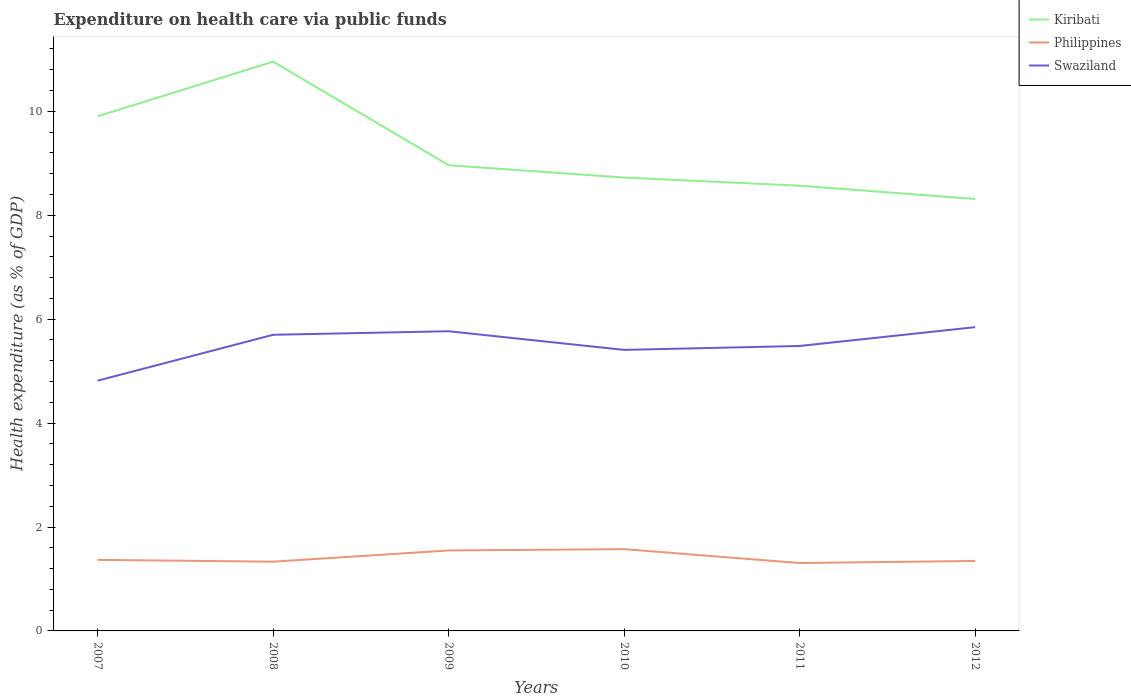How many different coloured lines are there?
Keep it short and to the point. 3. Is the number of lines equal to the number of legend labels?
Offer a terse response. Yes. Across all years, what is the maximum expenditure made on health care in Kiribati?
Offer a very short reply. 8.31. In which year was the expenditure made on health care in Philippines maximum?
Offer a terse response. 2011. What is the total expenditure made on health care in Philippines in the graph?
Keep it short and to the point. -0.04. What is the difference between the highest and the second highest expenditure made on health care in Philippines?
Keep it short and to the point. 0.27. What is the difference between the highest and the lowest expenditure made on health care in Kiribati?
Offer a terse response. 2. What is the difference between two consecutive major ticks on the Y-axis?
Give a very brief answer. 2. Does the graph contain any zero values?
Offer a very short reply. No. Does the graph contain grids?
Ensure brevity in your answer.  No. How many legend labels are there?
Your answer should be compact. 3. How are the legend labels stacked?
Offer a very short reply. Vertical. What is the title of the graph?
Provide a succinct answer. Expenditure on health care via public funds. Does "Iceland" appear as one of the legend labels in the graph?
Ensure brevity in your answer.  No. What is the label or title of the X-axis?
Give a very brief answer. Years. What is the label or title of the Y-axis?
Provide a succinct answer. Health expenditure (as % of GDP). What is the Health expenditure (as % of GDP) of Kiribati in 2007?
Keep it short and to the point. 9.9. What is the Health expenditure (as % of GDP) in Philippines in 2007?
Make the answer very short. 1.37. What is the Health expenditure (as % of GDP) of Swaziland in 2007?
Provide a short and direct response. 4.82. What is the Health expenditure (as % of GDP) of Kiribati in 2008?
Your answer should be compact. 10.96. What is the Health expenditure (as % of GDP) in Philippines in 2008?
Your answer should be very brief. 1.33. What is the Health expenditure (as % of GDP) of Swaziland in 2008?
Your answer should be very brief. 5.7. What is the Health expenditure (as % of GDP) of Kiribati in 2009?
Offer a terse response. 8.96. What is the Health expenditure (as % of GDP) in Philippines in 2009?
Give a very brief answer. 1.55. What is the Health expenditure (as % of GDP) of Swaziland in 2009?
Ensure brevity in your answer.  5.77. What is the Health expenditure (as % of GDP) of Kiribati in 2010?
Your answer should be compact. 8.73. What is the Health expenditure (as % of GDP) in Philippines in 2010?
Ensure brevity in your answer.  1.57. What is the Health expenditure (as % of GDP) in Swaziland in 2010?
Make the answer very short. 5.41. What is the Health expenditure (as % of GDP) of Kiribati in 2011?
Ensure brevity in your answer.  8.57. What is the Health expenditure (as % of GDP) of Philippines in 2011?
Give a very brief answer. 1.31. What is the Health expenditure (as % of GDP) of Swaziland in 2011?
Your response must be concise. 5.48. What is the Health expenditure (as % of GDP) of Kiribati in 2012?
Your response must be concise. 8.31. What is the Health expenditure (as % of GDP) of Philippines in 2012?
Make the answer very short. 1.35. What is the Health expenditure (as % of GDP) in Swaziland in 2012?
Your answer should be compact. 5.85. Across all years, what is the maximum Health expenditure (as % of GDP) in Kiribati?
Ensure brevity in your answer.  10.96. Across all years, what is the maximum Health expenditure (as % of GDP) in Philippines?
Your answer should be compact. 1.57. Across all years, what is the maximum Health expenditure (as % of GDP) in Swaziland?
Offer a terse response. 5.85. Across all years, what is the minimum Health expenditure (as % of GDP) in Kiribati?
Your answer should be very brief. 8.31. Across all years, what is the minimum Health expenditure (as % of GDP) of Philippines?
Your answer should be very brief. 1.31. Across all years, what is the minimum Health expenditure (as % of GDP) in Swaziland?
Provide a short and direct response. 4.82. What is the total Health expenditure (as % of GDP) in Kiribati in the graph?
Your answer should be compact. 55.43. What is the total Health expenditure (as % of GDP) in Philippines in the graph?
Offer a very short reply. 8.48. What is the total Health expenditure (as % of GDP) in Swaziland in the graph?
Provide a succinct answer. 33.02. What is the difference between the Health expenditure (as % of GDP) of Kiribati in 2007 and that in 2008?
Offer a terse response. -1.05. What is the difference between the Health expenditure (as % of GDP) in Philippines in 2007 and that in 2008?
Your answer should be very brief. 0.04. What is the difference between the Health expenditure (as % of GDP) in Swaziland in 2007 and that in 2008?
Keep it short and to the point. -0.88. What is the difference between the Health expenditure (as % of GDP) of Kiribati in 2007 and that in 2009?
Your response must be concise. 0.94. What is the difference between the Health expenditure (as % of GDP) of Philippines in 2007 and that in 2009?
Your response must be concise. -0.18. What is the difference between the Health expenditure (as % of GDP) of Swaziland in 2007 and that in 2009?
Your answer should be compact. -0.95. What is the difference between the Health expenditure (as % of GDP) in Kiribati in 2007 and that in 2010?
Provide a short and direct response. 1.18. What is the difference between the Health expenditure (as % of GDP) of Philippines in 2007 and that in 2010?
Keep it short and to the point. -0.21. What is the difference between the Health expenditure (as % of GDP) in Swaziland in 2007 and that in 2010?
Make the answer very short. -0.59. What is the difference between the Health expenditure (as % of GDP) in Kiribati in 2007 and that in 2011?
Keep it short and to the point. 1.34. What is the difference between the Health expenditure (as % of GDP) in Philippines in 2007 and that in 2011?
Give a very brief answer. 0.06. What is the difference between the Health expenditure (as % of GDP) of Swaziland in 2007 and that in 2011?
Make the answer very short. -0.67. What is the difference between the Health expenditure (as % of GDP) in Kiribati in 2007 and that in 2012?
Your answer should be very brief. 1.59. What is the difference between the Health expenditure (as % of GDP) of Philippines in 2007 and that in 2012?
Give a very brief answer. 0.02. What is the difference between the Health expenditure (as % of GDP) of Swaziland in 2007 and that in 2012?
Your answer should be very brief. -1.03. What is the difference between the Health expenditure (as % of GDP) of Kiribati in 2008 and that in 2009?
Your answer should be very brief. 1.99. What is the difference between the Health expenditure (as % of GDP) in Philippines in 2008 and that in 2009?
Make the answer very short. -0.22. What is the difference between the Health expenditure (as % of GDP) of Swaziland in 2008 and that in 2009?
Offer a very short reply. -0.07. What is the difference between the Health expenditure (as % of GDP) of Kiribati in 2008 and that in 2010?
Make the answer very short. 2.23. What is the difference between the Health expenditure (as % of GDP) of Philippines in 2008 and that in 2010?
Your answer should be very brief. -0.24. What is the difference between the Health expenditure (as % of GDP) of Swaziland in 2008 and that in 2010?
Make the answer very short. 0.29. What is the difference between the Health expenditure (as % of GDP) in Kiribati in 2008 and that in 2011?
Offer a terse response. 2.39. What is the difference between the Health expenditure (as % of GDP) of Philippines in 2008 and that in 2011?
Your answer should be very brief. 0.03. What is the difference between the Health expenditure (as % of GDP) in Swaziland in 2008 and that in 2011?
Keep it short and to the point. 0.22. What is the difference between the Health expenditure (as % of GDP) in Kiribati in 2008 and that in 2012?
Your answer should be very brief. 2.64. What is the difference between the Health expenditure (as % of GDP) in Philippines in 2008 and that in 2012?
Offer a terse response. -0.01. What is the difference between the Health expenditure (as % of GDP) of Swaziland in 2008 and that in 2012?
Provide a succinct answer. -0.15. What is the difference between the Health expenditure (as % of GDP) in Kiribati in 2009 and that in 2010?
Your response must be concise. 0.24. What is the difference between the Health expenditure (as % of GDP) of Philippines in 2009 and that in 2010?
Provide a succinct answer. -0.03. What is the difference between the Health expenditure (as % of GDP) of Swaziland in 2009 and that in 2010?
Your response must be concise. 0.36. What is the difference between the Health expenditure (as % of GDP) of Kiribati in 2009 and that in 2011?
Offer a very short reply. 0.39. What is the difference between the Health expenditure (as % of GDP) of Philippines in 2009 and that in 2011?
Offer a very short reply. 0.24. What is the difference between the Health expenditure (as % of GDP) of Swaziland in 2009 and that in 2011?
Make the answer very short. 0.28. What is the difference between the Health expenditure (as % of GDP) of Kiribati in 2009 and that in 2012?
Provide a succinct answer. 0.65. What is the difference between the Health expenditure (as % of GDP) of Philippines in 2009 and that in 2012?
Make the answer very short. 0.2. What is the difference between the Health expenditure (as % of GDP) in Swaziland in 2009 and that in 2012?
Provide a succinct answer. -0.08. What is the difference between the Health expenditure (as % of GDP) in Kiribati in 2010 and that in 2011?
Offer a very short reply. 0.16. What is the difference between the Health expenditure (as % of GDP) in Philippines in 2010 and that in 2011?
Ensure brevity in your answer.  0.27. What is the difference between the Health expenditure (as % of GDP) in Swaziland in 2010 and that in 2011?
Offer a terse response. -0.08. What is the difference between the Health expenditure (as % of GDP) in Kiribati in 2010 and that in 2012?
Give a very brief answer. 0.41. What is the difference between the Health expenditure (as % of GDP) of Philippines in 2010 and that in 2012?
Ensure brevity in your answer.  0.23. What is the difference between the Health expenditure (as % of GDP) of Swaziland in 2010 and that in 2012?
Offer a very short reply. -0.44. What is the difference between the Health expenditure (as % of GDP) in Kiribati in 2011 and that in 2012?
Offer a terse response. 0.26. What is the difference between the Health expenditure (as % of GDP) of Philippines in 2011 and that in 2012?
Provide a short and direct response. -0.04. What is the difference between the Health expenditure (as % of GDP) of Swaziland in 2011 and that in 2012?
Offer a very short reply. -0.36. What is the difference between the Health expenditure (as % of GDP) of Kiribati in 2007 and the Health expenditure (as % of GDP) of Philippines in 2008?
Offer a terse response. 8.57. What is the difference between the Health expenditure (as % of GDP) in Kiribati in 2007 and the Health expenditure (as % of GDP) in Swaziland in 2008?
Give a very brief answer. 4.21. What is the difference between the Health expenditure (as % of GDP) in Philippines in 2007 and the Health expenditure (as % of GDP) in Swaziland in 2008?
Your answer should be very brief. -4.33. What is the difference between the Health expenditure (as % of GDP) in Kiribati in 2007 and the Health expenditure (as % of GDP) in Philippines in 2009?
Give a very brief answer. 8.36. What is the difference between the Health expenditure (as % of GDP) in Kiribati in 2007 and the Health expenditure (as % of GDP) in Swaziland in 2009?
Offer a very short reply. 4.14. What is the difference between the Health expenditure (as % of GDP) of Philippines in 2007 and the Health expenditure (as % of GDP) of Swaziland in 2009?
Provide a succinct answer. -4.4. What is the difference between the Health expenditure (as % of GDP) in Kiribati in 2007 and the Health expenditure (as % of GDP) in Philippines in 2010?
Provide a succinct answer. 8.33. What is the difference between the Health expenditure (as % of GDP) in Kiribati in 2007 and the Health expenditure (as % of GDP) in Swaziland in 2010?
Provide a succinct answer. 4.5. What is the difference between the Health expenditure (as % of GDP) in Philippines in 2007 and the Health expenditure (as % of GDP) in Swaziland in 2010?
Keep it short and to the point. -4.04. What is the difference between the Health expenditure (as % of GDP) in Kiribati in 2007 and the Health expenditure (as % of GDP) in Philippines in 2011?
Provide a short and direct response. 8.6. What is the difference between the Health expenditure (as % of GDP) in Kiribati in 2007 and the Health expenditure (as % of GDP) in Swaziland in 2011?
Your answer should be very brief. 4.42. What is the difference between the Health expenditure (as % of GDP) of Philippines in 2007 and the Health expenditure (as % of GDP) of Swaziland in 2011?
Your response must be concise. -4.12. What is the difference between the Health expenditure (as % of GDP) in Kiribati in 2007 and the Health expenditure (as % of GDP) in Philippines in 2012?
Ensure brevity in your answer.  8.56. What is the difference between the Health expenditure (as % of GDP) in Kiribati in 2007 and the Health expenditure (as % of GDP) in Swaziland in 2012?
Ensure brevity in your answer.  4.06. What is the difference between the Health expenditure (as % of GDP) in Philippines in 2007 and the Health expenditure (as % of GDP) in Swaziland in 2012?
Provide a succinct answer. -4.48. What is the difference between the Health expenditure (as % of GDP) of Kiribati in 2008 and the Health expenditure (as % of GDP) of Philippines in 2009?
Keep it short and to the point. 9.41. What is the difference between the Health expenditure (as % of GDP) of Kiribati in 2008 and the Health expenditure (as % of GDP) of Swaziland in 2009?
Keep it short and to the point. 5.19. What is the difference between the Health expenditure (as % of GDP) in Philippines in 2008 and the Health expenditure (as % of GDP) in Swaziland in 2009?
Make the answer very short. -4.44. What is the difference between the Health expenditure (as % of GDP) of Kiribati in 2008 and the Health expenditure (as % of GDP) of Philippines in 2010?
Your answer should be compact. 9.38. What is the difference between the Health expenditure (as % of GDP) in Kiribati in 2008 and the Health expenditure (as % of GDP) in Swaziland in 2010?
Provide a succinct answer. 5.55. What is the difference between the Health expenditure (as % of GDP) in Philippines in 2008 and the Health expenditure (as % of GDP) in Swaziland in 2010?
Provide a succinct answer. -4.08. What is the difference between the Health expenditure (as % of GDP) in Kiribati in 2008 and the Health expenditure (as % of GDP) in Philippines in 2011?
Make the answer very short. 9.65. What is the difference between the Health expenditure (as % of GDP) of Kiribati in 2008 and the Health expenditure (as % of GDP) of Swaziland in 2011?
Your answer should be very brief. 5.47. What is the difference between the Health expenditure (as % of GDP) of Philippines in 2008 and the Health expenditure (as % of GDP) of Swaziland in 2011?
Your answer should be very brief. -4.15. What is the difference between the Health expenditure (as % of GDP) in Kiribati in 2008 and the Health expenditure (as % of GDP) in Philippines in 2012?
Make the answer very short. 9.61. What is the difference between the Health expenditure (as % of GDP) in Kiribati in 2008 and the Health expenditure (as % of GDP) in Swaziland in 2012?
Give a very brief answer. 5.11. What is the difference between the Health expenditure (as % of GDP) of Philippines in 2008 and the Health expenditure (as % of GDP) of Swaziland in 2012?
Ensure brevity in your answer.  -4.51. What is the difference between the Health expenditure (as % of GDP) in Kiribati in 2009 and the Health expenditure (as % of GDP) in Philippines in 2010?
Ensure brevity in your answer.  7.39. What is the difference between the Health expenditure (as % of GDP) in Kiribati in 2009 and the Health expenditure (as % of GDP) in Swaziland in 2010?
Your answer should be compact. 3.55. What is the difference between the Health expenditure (as % of GDP) of Philippines in 2009 and the Health expenditure (as % of GDP) of Swaziland in 2010?
Your response must be concise. -3.86. What is the difference between the Health expenditure (as % of GDP) in Kiribati in 2009 and the Health expenditure (as % of GDP) in Philippines in 2011?
Offer a terse response. 7.66. What is the difference between the Health expenditure (as % of GDP) of Kiribati in 2009 and the Health expenditure (as % of GDP) of Swaziland in 2011?
Your response must be concise. 3.48. What is the difference between the Health expenditure (as % of GDP) of Philippines in 2009 and the Health expenditure (as % of GDP) of Swaziland in 2011?
Provide a succinct answer. -3.94. What is the difference between the Health expenditure (as % of GDP) of Kiribati in 2009 and the Health expenditure (as % of GDP) of Philippines in 2012?
Provide a succinct answer. 7.62. What is the difference between the Health expenditure (as % of GDP) in Kiribati in 2009 and the Health expenditure (as % of GDP) in Swaziland in 2012?
Provide a short and direct response. 3.12. What is the difference between the Health expenditure (as % of GDP) of Philippines in 2009 and the Health expenditure (as % of GDP) of Swaziland in 2012?
Make the answer very short. -4.3. What is the difference between the Health expenditure (as % of GDP) in Kiribati in 2010 and the Health expenditure (as % of GDP) in Philippines in 2011?
Give a very brief answer. 7.42. What is the difference between the Health expenditure (as % of GDP) of Kiribati in 2010 and the Health expenditure (as % of GDP) of Swaziland in 2011?
Keep it short and to the point. 3.24. What is the difference between the Health expenditure (as % of GDP) in Philippines in 2010 and the Health expenditure (as % of GDP) in Swaziland in 2011?
Provide a short and direct response. -3.91. What is the difference between the Health expenditure (as % of GDP) of Kiribati in 2010 and the Health expenditure (as % of GDP) of Philippines in 2012?
Your response must be concise. 7.38. What is the difference between the Health expenditure (as % of GDP) in Kiribati in 2010 and the Health expenditure (as % of GDP) in Swaziland in 2012?
Offer a terse response. 2.88. What is the difference between the Health expenditure (as % of GDP) in Philippines in 2010 and the Health expenditure (as % of GDP) in Swaziland in 2012?
Give a very brief answer. -4.27. What is the difference between the Health expenditure (as % of GDP) in Kiribati in 2011 and the Health expenditure (as % of GDP) in Philippines in 2012?
Keep it short and to the point. 7.22. What is the difference between the Health expenditure (as % of GDP) of Kiribati in 2011 and the Health expenditure (as % of GDP) of Swaziland in 2012?
Offer a very short reply. 2.72. What is the difference between the Health expenditure (as % of GDP) in Philippines in 2011 and the Health expenditure (as % of GDP) in Swaziland in 2012?
Provide a short and direct response. -4.54. What is the average Health expenditure (as % of GDP) in Kiribati per year?
Give a very brief answer. 9.24. What is the average Health expenditure (as % of GDP) in Philippines per year?
Give a very brief answer. 1.41. What is the average Health expenditure (as % of GDP) of Swaziland per year?
Offer a very short reply. 5.5. In the year 2007, what is the difference between the Health expenditure (as % of GDP) of Kiribati and Health expenditure (as % of GDP) of Philippines?
Give a very brief answer. 8.54. In the year 2007, what is the difference between the Health expenditure (as % of GDP) in Kiribati and Health expenditure (as % of GDP) in Swaziland?
Offer a terse response. 5.09. In the year 2007, what is the difference between the Health expenditure (as % of GDP) of Philippines and Health expenditure (as % of GDP) of Swaziland?
Your answer should be compact. -3.45. In the year 2008, what is the difference between the Health expenditure (as % of GDP) in Kiribati and Health expenditure (as % of GDP) in Philippines?
Offer a very short reply. 9.62. In the year 2008, what is the difference between the Health expenditure (as % of GDP) in Kiribati and Health expenditure (as % of GDP) in Swaziland?
Give a very brief answer. 5.26. In the year 2008, what is the difference between the Health expenditure (as % of GDP) of Philippines and Health expenditure (as % of GDP) of Swaziland?
Offer a very short reply. -4.37. In the year 2009, what is the difference between the Health expenditure (as % of GDP) of Kiribati and Health expenditure (as % of GDP) of Philippines?
Ensure brevity in your answer.  7.41. In the year 2009, what is the difference between the Health expenditure (as % of GDP) in Kiribati and Health expenditure (as % of GDP) in Swaziland?
Give a very brief answer. 3.2. In the year 2009, what is the difference between the Health expenditure (as % of GDP) of Philippines and Health expenditure (as % of GDP) of Swaziland?
Provide a succinct answer. -4.22. In the year 2010, what is the difference between the Health expenditure (as % of GDP) of Kiribati and Health expenditure (as % of GDP) of Philippines?
Keep it short and to the point. 7.15. In the year 2010, what is the difference between the Health expenditure (as % of GDP) in Kiribati and Health expenditure (as % of GDP) in Swaziland?
Offer a terse response. 3.32. In the year 2010, what is the difference between the Health expenditure (as % of GDP) in Philippines and Health expenditure (as % of GDP) in Swaziland?
Your response must be concise. -3.84. In the year 2011, what is the difference between the Health expenditure (as % of GDP) of Kiribati and Health expenditure (as % of GDP) of Philippines?
Make the answer very short. 7.26. In the year 2011, what is the difference between the Health expenditure (as % of GDP) in Kiribati and Health expenditure (as % of GDP) in Swaziland?
Provide a succinct answer. 3.08. In the year 2011, what is the difference between the Health expenditure (as % of GDP) of Philippines and Health expenditure (as % of GDP) of Swaziland?
Provide a succinct answer. -4.18. In the year 2012, what is the difference between the Health expenditure (as % of GDP) of Kiribati and Health expenditure (as % of GDP) of Philippines?
Offer a terse response. 6.97. In the year 2012, what is the difference between the Health expenditure (as % of GDP) of Kiribati and Health expenditure (as % of GDP) of Swaziland?
Your answer should be very brief. 2.47. In the year 2012, what is the difference between the Health expenditure (as % of GDP) in Philippines and Health expenditure (as % of GDP) in Swaziland?
Provide a succinct answer. -4.5. What is the ratio of the Health expenditure (as % of GDP) in Kiribati in 2007 to that in 2008?
Provide a short and direct response. 0.9. What is the ratio of the Health expenditure (as % of GDP) of Philippines in 2007 to that in 2008?
Provide a short and direct response. 1.03. What is the ratio of the Health expenditure (as % of GDP) in Swaziland in 2007 to that in 2008?
Your response must be concise. 0.84. What is the ratio of the Health expenditure (as % of GDP) of Kiribati in 2007 to that in 2009?
Offer a terse response. 1.1. What is the ratio of the Health expenditure (as % of GDP) of Philippines in 2007 to that in 2009?
Provide a short and direct response. 0.88. What is the ratio of the Health expenditure (as % of GDP) in Swaziland in 2007 to that in 2009?
Provide a short and direct response. 0.83. What is the ratio of the Health expenditure (as % of GDP) of Kiribati in 2007 to that in 2010?
Give a very brief answer. 1.14. What is the ratio of the Health expenditure (as % of GDP) in Philippines in 2007 to that in 2010?
Your answer should be very brief. 0.87. What is the ratio of the Health expenditure (as % of GDP) of Swaziland in 2007 to that in 2010?
Your response must be concise. 0.89. What is the ratio of the Health expenditure (as % of GDP) in Kiribati in 2007 to that in 2011?
Offer a terse response. 1.16. What is the ratio of the Health expenditure (as % of GDP) of Philippines in 2007 to that in 2011?
Keep it short and to the point. 1.05. What is the ratio of the Health expenditure (as % of GDP) of Swaziland in 2007 to that in 2011?
Ensure brevity in your answer.  0.88. What is the ratio of the Health expenditure (as % of GDP) of Kiribati in 2007 to that in 2012?
Your answer should be very brief. 1.19. What is the ratio of the Health expenditure (as % of GDP) in Philippines in 2007 to that in 2012?
Provide a succinct answer. 1.02. What is the ratio of the Health expenditure (as % of GDP) of Swaziland in 2007 to that in 2012?
Provide a short and direct response. 0.82. What is the ratio of the Health expenditure (as % of GDP) of Kiribati in 2008 to that in 2009?
Give a very brief answer. 1.22. What is the ratio of the Health expenditure (as % of GDP) of Philippines in 2008 to that in 2009?
Make the answer very short. 0.86. What is the ratio of the Health expenditure (as % of GDP) in Swaziland in 2008 to that in 2009?
Make the answer very short. 0.99. What is the ratio of the Health expenditure (as % of GDP) in Kiribati in 2008 to that in 2010?
Your response must be concise. 1.26. What is the ratio of the Health expenditure (as % of GDP) in Philippines in 2008 to that in 2010?
Your answer should be very brief. 0.85. What is the ratio of the Health expenditure (as % of GDP) of Swaziland in 2008 to that in 2010?
Your response must be concise. 1.05. What is the ratio of the Health expenditure (as % of GDP) in Kiribati in 2008 to that in 2011?
Your answer should be very brief. 1.28. What is the ratio of the Health expenditure (as % of GDP) of Philippines in 2008 to that in 2011?
Give a very brief answer. 1.02. What is the ratio of the Health expenditure (as % of GDP) in Swaziland in 2008 to that in 2011?
Give a very brief answer. 1.04. What is the ratio of the Health expenditure (as % of GDP) of Kiribati in 2008 to that in 2012?
Provide a short and direct response. 1.32. What is the ratio of the Health expenditure (as % of GDP) in Swaziland in 2008 to that in 2012?
Keep it short and to the point. 0.97. What is the ratio of the Health expenditure (as % of GDP) of Kiribati in 2009 to that in 2010?
Your answer should be very brief. 1.03. What is the ratio of the Health expenditure (as % of GDP) of Philippines in 2009 to that in 2010?
Keep it short and to the point. 0.98. What is the ratio of the Health expenditure (as % of GDP) in Swaziland in 2009 to that in 2010?
Provide a succinct answer. 1.07. What is the ratio of the Health expenditure (as % of GDP) of Kiribati in 2009 to that in 2011?
Ensure brevity in your answer.  1.05. What is the ratio of the Health expenditure (as % of GDP) of Philippines in 2009 to that in 2011?
Your answer should be compact. 1.19. What is the ratio of the Health expenditure (as % of GDP) of Swaziland in 2009 to that in 2011?
Provide a succinct answer. 1.05. What is the ratio of the Health expenditure (as % of GDP) in Kiribati in 2009 to that in 2012?
Make the answer very short. 1.08. What is the ratio of the Health expenditure (as % of GDP) of Philippines in 2009 to that in 2012?
Give a very brief answer. 1.15. What is the ratio of the Health expenditure (as % of GDP) of Swaziland in 2009 to that in 2012?
Your answer should be compact. 0.99. What is the ratio of the Health expenditure (as % of GDP) in Kiribati in 2010 to that in 2011?
Offer a very short reply. 1.02. What is the ratio of the Health expenditure (as % of GDP) in Philippines in 2010 to that in 2011?
Your answer should be very brief. 1.2. What is the ratio of the Health expenditure (as % of GDP) in Swaziland in 2010 to that in 2011?
Offer a terse response. 0.99. What is the ratio of the Health expenditure (as % of GDP) in Kiribati in 2010 to that in 2012?
Provide a succinct answer. 1.05. What is the ratio of the Health expenditure (as % of GDP) of Philippines in 2010 to that in 2012?
Make the answer very short. 1.17. What is the ratio of the Health expenditure (as % of GDP) of Swaziland in 2010 to that in 2012?
Ensure brevity in your answer.  0.93. What is the ratio of the Health expenditure (as % of GDP) of Kiribati in 2011 to that in 2012?
Offer a very short reply. 1.03. What is the ratio of the Health expenditure (as % of GDP) in Philippines in 2011 to that in 2012?
Ensure brevity in your answer.  0.97. What is the ratio of the Health expenditure (as % of GDP) of Swaziland in 2011 to that in 2012?
Give a very brief answer. 0.94. What is the difference between the highest and the second highest Health expenditure (as % of GDP) of Kiribati?
Your answer should be compact. 1.05. What is the difference between the highest and the second highest Health expenditure (as % of GDP) in Philippines?
Your answer should be compact. 0.03. What is the difference between the highest and the second highest Health expenditure (as % of GDP) in Swaziland?
Provide a succinct answer. 0.08. What is the difference between the highest and the lowest Health expenditure (as % of GDP) in Kiribati?
Keep it short and to the point. 2.64. What is the difference between the highest and the lowest Health expenditure (as % of GDP) of Philippines?
Provide a succinct answer. 0.27. What is the difference between the highest and the lowest Health expenditure (as % of GDP) of Swaziland?
Keep it short and to the point. 1.03. 